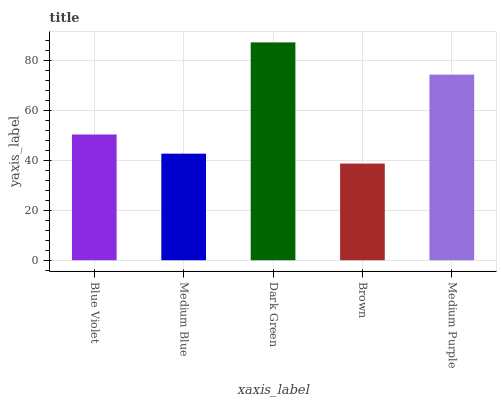Is Brown the minimum?
Answer yes or no. Yes. Is Dark Green the maximum?
Answer yes or no. Yes. Is Medium Blue the minimum?
Answer yes or no. No. Is Medium Blue the maximum?
Answer yes or no. No. Is Blue Violet greater than Medium Blue?
Answer yes or no. Yes. Is Medium Blue less than Blue Violet?
Answer yes or no. Yes. Is Medium Blue greater than Blue Violet?
Answer yes or no. No. Is Blue Violet less than Medium Blue?
Answer yes or no. No. Is Blue Violet the high median?
Answer yes or no. Yes. Is Blue Violet the low median?
Answer yes or no. Yes. Is Dark Green the high median?
Answer yes or no. No. Is Medium Blue the low median?
Answer yes or no. No. 